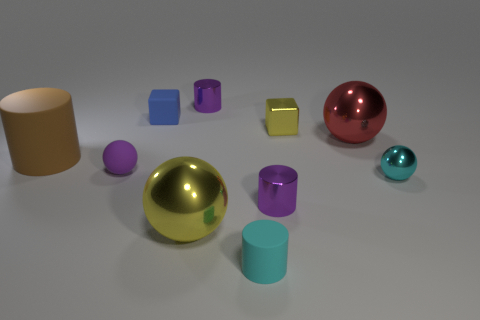What is the sphere that is behind the big brown rubber cylinder made of?
Your response must be concise. Metal. How many large rubber objects have the same shape as the tiny purple matte object?
Offer a very short reply. 0. The purple object that is on the left side of the tiny purple metallic thing that is behind the tiny cyan metallic ball is made of what material?
Your response must be concise. Rubber. There is a tiny object that is the same color as the tiny shiny sphere; what is its shape?
Provide a succinct answer. Cylinder. Are there any spheres that have the same material as the blue thing?
Offer a terse response. Yes. What is the shape of the tiny blue thing?
Give a very brief answer. Cube. How many small purple rubber things are there?
Your answer should be very brief. 1. The tiny object to the right of the small yellow object that is left of the tiny shiny sphere is what color?
Keep it short and to the point. Cyan. What is the color of the metallic sphere that is the same size as the blue matte object?
Your answer should be compact. Cyan. Are there any spheres that have the same color as the small rubber cylinder?
Offer a very short reply. Yes. 